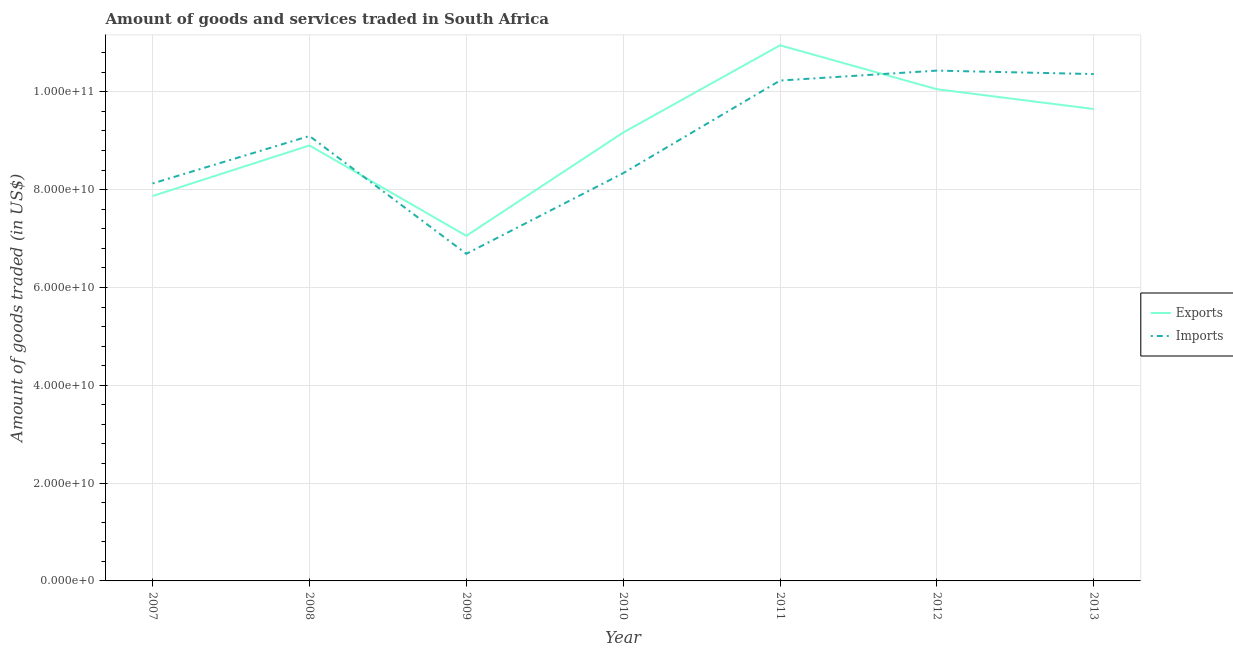How many different coloured lines are there?
Your answer should be very brief. 2. What is the amount of goods imported in 2012?
Keep it short and to the point. 1.04e+11. Across all years, what is the maximum amount of goods imported?
Offer a very short reply. 1.04e+11. Across all years, what is the minimum amount of goods imported?
Offer a very short reply. 6.69e+1. In which year was the amount of goods exported maximum?
Offer a terse response. 2011. In which year was the amount of goods exported minimum?
Keep it short and to the point. 2009. What is the total amount of goods exported in the graph?
Keep it short and to the point. 6.36e+11. What is the difference between the amount of goods exported in 2007 and that in 2008?
Provide a short and direct response. -1.03e+1. What is the difference between the amount of goods exported in 2010 and the amount of goods imported in 2008?
Your answer should be compact. 7.09e+08. What is the average amount of goods imported per year?
Your response must be concise. 9.04e+1. In the year 2010, what is the difference between the amount of goods exported and amount of goods imported?
Ensure brevity in your answer.  8.31e+09. In how many years, is the amount of goods exported greater than 92000000000 US$?
Make the answer very short. 3. What is the ratio of the amount of goods imported in 2007 to that in 2011?
Ensure brevity in your answer.  0.79. What is the difference between the highest and the second highest amount of goods exported?
Provide a short and direct response. 8.98e+09. What is the difference between the highest and the lowest amount of goods imported?
Offer a terse response. 3.75e+1. In how many years, is the amount of goods imported greater than the average amount of goods imported taken over all years?
Your response must be concise. 4. Is the amount of goods exported strictly greater than the amount of goods imported over the years?
Your answer should be very brief. No. How many years are there in the graph?
Provide a succinct answer. 7. What is the difference between two consecutive major ticks on the Y-axis?
Provide a short and direct response. 2.00e+1. Does the graph contain any zero values?
Ensure brevity in your answer.  No. Where does the legend appear in the graph?
Offer a terse response. Center right. How many legend labels are there?
Your response must be concise. 2. What is the title of the graph?
Provide a succinct answer. Amount of goods and services traded in South Africa. Does "Not attending school" appear as one of the legend labels in the graph?
Make the answer very short. No. What is the label or title of the X-axis?
Make the answer very short. Year. What is the label or title of the Y-axis?
Make the answer very short. Amount of goods traded (in US$). What is the Amount of goods traded (in US$) of Exports in 2007?
Provide a short and direct response. 7.87e+1. What is the Amount of goods traded (in US$) of Imports in 2007?
Keep it short and to the point. 8.13e+1. What is the Amount of goods traded (in US$) of Exports in 2008?
Offer a very short reply. 8.90e+1. What is the Amount of goods traded (in US$) of Imports in 2008?
Offer a terse response. 9.10e+1. What is the Amount of goods traded (in US$) of Exports in 2009?
Keep it short and to the point. 7.06e+1. What is the Amount of goods traded (in US$) of Imports in 2009?
Give a very brief answer. 6.69e+1. What is the Amount of goods traded (in US$) of Exports in 2010?
Give a very brief answer. 9.17e+1. What is the Amount of goods traded (in US$) in Imports in 2010?
Give a very brief answer. 8.34e+1. What is the Amount of goods traded (in US$) of Exports in 2011?
Offer a very short reply. 1.10e+11. What is the Amount of goods traded (in US$) of Imports in 2011?
Your answer should be very brief. 1.02e+11. What is the Amount of goods traded (in US$) of Exports in 2012?
Your answer should be very brief. 1.01e+11. What is the Amount of goods traded (in US$) in Imports in 2012?
Provide a succinct answer. 1.04e+11. What is the Amount of goods traded (in US$) of Exports in 2013?
Your response must be concise. 9.65e+1. What is the Amount of goods traded (in US$) in Imports in 2013?
Give a very brief answer. 1.04e+11. Across all years, what is the maximum Amount of goods traded (in US$) in Exports?
Keep it short and to the point. 1.10e+11. Across all years, what is the maximum Amount of goods traded (in US$) of Imports?
Your answer should be compact. 1.04e+11. Across all years, what is the minimum Amount of goods traded (in US$) of Exports?
Offer a terse response. 7.06e+1. Across all years, what is the minimum Amount of goods traded (in US$) in Imports?
Provide a succinct answer. 6.69e+1. What is the total Amount of goods traded (in US$) of Exports in the graph?
Ensure brevity in your answer.  6.36e+11. What is the total Amount of goods traded (in US$) in Imports in the graph?
Provide a short and direct response. 6.33e+11. What is the difference between the Amount of goods traded (in US$) in Exports in 2007 and that in 2008?
Your answer should be very brief. -1.03e+1. What is the difference between the Amount of goods traded (in US$) of Imports in 2007 and that in 2008?
Your response must be concise. -9.70e+09. What is the difference between the Amount of goods traded (in US$) of Exports in 2007 and that in 2009?
Give a very brief answer. 8.14e+09. What is the difference between the Amount of goods traded (in US$) of Imports in 2007 and that in 2009?
Give a very brief answer. 1.44e+1. What is the difference between the Amount of goods traded (in US$) of Exports in 2007 and that in 2010?
Provide a succinct answer. -1.30e+1. What is the difference between the Amount of goods traded (in US$) in Imports in 2007 and that in 2010?
Your answer should be compact. -2.10e+09. What is the difference between the Amount of goods traded (in US$) in Exports in 2007 and that in 2011?
Provide a short and direct response. -3.08e+1. What is the difference between the Amount of goods traded (in US$) of Imports in 2007 and that in 2011?
Keep it short and to the point. -2.10e+1. What is the difference between the Amount of goods traded (in US$) in Exports in 2007 and that in 2012?
Give a very brief answer. -2.18e+1. What is the difference between the Amount of goods traded (in US$) in Imports in 2007 and that in 2012?
Keep it short and to the point. -2.31e+1. What is the difference between the Amount of goods traded (in US$) in Exports in 2007 and that in 2013?
Your response must be concise. -1.78e+1. What is the difference between the Amount of goods traded (in US$) in Imports in 2007 and that in 2013?
Offer a very short reply. -2.24e+1. What is the difference between the Amount of goods traded (in US$) in Exports in 2008 and that in 2009?
Your response must be concise. 1.85e+1. What is the difference between the Amount of goods traded (in US$) of Imports in 2008 and that in 2009?
Your answer should be very brief. 2.41e+1. What is the difference between the Amount of goods traded (in US$) of Exports in 2008 and that in 2010?
Ensure brevity in your answer.  -2.64e+09. What is the difference between the Amount of goods traded (in US$) in Imports in 2008 and that in 2010?
Offer a terse response. 7.60e+09. What is the difference between the Amount of goods traded (in US$) in Exports in 2008 and that in 2011?
Give a very brief answer. -2.05e+1. What is the difference between the Amount of goods traded (in US$) of Imports in 2008 and that in 2011?
Provide a succinct answer. -1.13e+1. What is the difference between the Amount of goods traded (in US$) in Exports in 2008 and that in 2012?
Make the answer very short. -1.15e+1. What is the difference between the Amount of goods traded (in US$) of Imports in 2008 and that in 2012?
Offer a very short reply. -1.34e+1. What is the difference between the Amount of goods traded (in US$) of Exports in 2008 and that in 2013?
Offer a terse response. -7.45e+09. What is the difference between the Amount of goods traded (in US$) of Imports in 2008 and that in 2013?
Provide a short and direct response. -1.27e+1. What is the difference between the Amount of goods traded (in US$) in Exports in 2009 and that in 2010?
Provide a short and direct response. -2.11e+1. What is the difference between the Amount of goods traded (in US$) of Imports in 2009 and that in 2010?
Keep it short and to the point. -1.65e+1. What is the difference between the Amount of goods traded (in US$) of Exports in 2009 and that in 2011?
Your response must be concise. -3.90e+1. What is the difference between the Amount of goods traded (in US$) in Imports in 2009 and that in 2011?
Your response must be concise. -3.54e+1. What is the difference between the Amount of goods traded (in US$) in Exports in 2009 and that in 2012?
Provide a succinct answer. -3.00e+1. What is the difference between the Amount of goods traded (in US$) in Imports in 2009 and that in 2012?
Your answer should be very brief. -3.75e+1. What is the difference between the Amount of goods traded (in US$) in Exports in 2009 and that in 2013?
Provide a succinct answer. -2.59e+1. What is the difference between the Amount of goods traded (in US$) in Imports in 2009 and that in 2013?
Ensure brevity in your answer.  -3.67e+1. What is the difference between the Amount of goods traded (in US$) in Exports in 2010 and that in 2011?
Keep it short and to the point. -1.78e+1. What is the difference between the Amount of goods traded (in US$) in Imports in 2010 and that in 2011?
Ensure brevity in your answer.  -1.89e+1. What is the difference between the Amount of goods traded (in US$) in Exports in 2010 and that in 2012?
Keep it short and to the point. -8.85e+09. What is the difference between the Amount of goods traded (in US$) of Imports in 2010 and that in 2012?
Your answer should be compact. -2.10e+1. What is the difference between the Amount of goods traded (in US$) of Exports in 2010 and that in 2013?
Make the answer very short. -4.81e+09. What is the difference between the Amount of goods traded (in US$) in Imports in 2010 and that in 2013?
Your answer should be compact. -2.03e+1. What is the difference between the Amount of goods traded (in US$) of Exports in 2011 and that in 2012?
Make the answer very short. 8.98e+09. What is the difference between the Amount of goods traded (in US$) in Imports in 2011 and that in 2012?
Your answer should be compact. -2.03e+09. What is the difference between the Amount of goods traded (in US$) of Exports in 2011 and that in 2013?
Offer a very short reply. 1.30e+1. What is the difference between the Amount of goods traded (in US$) of Imports in 2011 and that in 2013?
Provide a short and direct response. -1.33e+09. What is the difference between the Amount of goods traded (in US$) in Exports in 2012 and that in 2013?
Your answer should be very brief. 4.04e+09. What is the difference between the Amount of goods traded (in US$) of Imports in 2012 and that in 2013?
Make the answer very short. 7.08e+08. What is the difference between the Amount of goods traded (in US$) in Exports in 2007 and the Amount of goods traded (in US$) in Imports in 2008?
Offer a very short reply. -1.23e+1. What is the difference between the Amount of goods traded (in US$) in Exports in 2007 and the Amount of goods traded (in US$) in Imports in 2009?
Provide a short and direct response. 1.18e+1. What is the difference between the Amount of goods traded (in US$) in Exports in 2007 and the Amount of goods traded (in US$) in Imports in 2010?
Your answer should be compact. -4.67e+09. What is the difference between the Amount of goods traded (in US$) of Exports in 2007 and the Amount of goods traded (in US$) of Imports in 2011?
Make the answer very short. -2.36e+1. What is the difference between the Amount of goods traded (in US$) in Exports in 2007 and the Amount of goods traded (in US$) in Imports in 2012?
Offer a terse response. -2.56e+1. What is the difference between the Amount of goods traded (in US$) of Exports in 2007 and the Amount of goods traded (in US$) of Imports in 2013?
Your response must be concise. -2.49e+1. What is the difference between the Amount of goods traded (in US$) in Exports in 2008 and the Amount of goods traded (in US$) in Imports in 2009?
Offer a terse response. 2.21e+1. What is the difference between the Amount of goods traded (in US$) of Exports in 2008 and the Amount of goods traded (in US$) of Imports in 2010?
Offer a terse response. 5.67e+09. What is the difference between the Amount of goods traded (in US$) of Exports in 2008 and the Amount of goods traded (in US$) of Imports in 2011?
Your answer should be very brief. -1.33e+1. What is the difference between the Amount of goods traded (in US$) in Exports in 2008 and the Amount of goods traded (in US$) in Imports in 2012?
Offer a very short reply. -1.53e+1. What is the difference between the Amount of goods traded (in US$) of Exports in 2008 and the Amount of goods traded (in US$) of Imports in 2013?
Your response must be concise. -1.46e+1. What is the difference between the Amount of goods traded (in US$) of Exports in 2009 and the Amount of goods traded (in US$) of Imports in 2010?
Your answer should be very brief. -1.28e+1. What is the difference between the Amount of goods traded (in US$) of Exports in 2009 and the Amount of goods traded (in US$) of Imports in 2011?
Your answer should be very brief. -3.17e+1. What is the difference between the Amount of goods traded (in US$) in Exports in 2009 and the Amount of goods traded (in US$) in Imports in 2012?
Your answer should be compact. -3.38e+1. What is the difference between the Amount of goods traded (in US$) of Exports in 2009 and the Amount of goods traded (in US$) of Imports in 2013?
Provide a short and direct response. -3.31e+1. What is the difference between the Amount of goods traded (in US$) of Exports in 2010 and the Amount of goods traded (in US$) of Imports in 2011?
Provide a short and direct response. -1.06e+1. What is the difference between the Amount of goods traded (in US$) in Exports in 2010 and the Amount of goods traded (in US$) in Imports in 2012?
Keep it short and to the point. -1.27e+1. What is the difference between the Amount of goods traded (in US$) of Exports in 2010 and the Amount of goods traded (in US$) of Imports in 2013?
Ensure brevity in your answer.  -1.20e+1. What is the difference between the Amount of goods traded (in US$) in Exports in 2011 and the Amount of goods traded (in US$) in Imports in 2012?
Offer a very short reply. 5.17e+09. What is the difference between the Amount of goods traded (in US$) of Exports in 2011 and the Amount of goods traded (in US$) of Imports in 2013?
Make the answer very short. 5.88e+09. What is the difference between the Amount of goods traded (in US$) of Exports in 2012 and the Amount of goods traded (in US$) of Imports in 2013?
Provide a succinct answer. -3.10e+09. What is the average Amount of goods traded (in US$) in Exports per year?
Ensure brevity in your answer.  9.09e+1. What is the average Amount of goods traded (in US$) of Imports per year?
Offer a very short reply. 9.04e+1. In the year 2007, what is the difference between the Amount of goods traded (in US$) of Exports and Amount of goods traded (in US$) of Imports?
Provide a short and direct response. -2.57e+09. In the year 2008, what is the difference between the Amount of goods traded (in US$) in Exports and Amount of goods traded (in US$) in Imports?
Your response must be concise. -1.93e+09. In the year 2009, what is the difference between the Amount of goods traded (in US$) of Exports and Amount of goods traded (in US$) of Imports?
Provide a succinct answer. 3.67e+09. In the year 2010, what is the difference between the Amount of goods traded (in US$) in Exports and Amount of goods traded (in US$) in Imports?
Offer a very short reply. 8.31e+09. In the year 2011, what is the difference between the Amount of goods traded (in US$) of Exports and Amount of goods traded (in US$) of Imports?
Provide a short and direct response. 7.21e+09. In the year 2012, what is the difference between the Amount of goods traded (in US$) in Exports and Amount of goods traded (in US$) in Imports?
Ensure brevity in your answer.  -3.81e+09. In the year 2013, what is the difference between the Amount of goods traded (in US$) of Exports and Amount of goods traded (in US$) of Imports?
Provide a succinct answer. -7.14e+09. What is the ratio of the Amount of goods traded (in US$) in Exports in 2007 to that in 2008?
Offer a very short reply. 0.88. What is the ratio of the Amount of goods traded (in US$) of Imports in 2007 to that in 2008?
Offer a terse response. 0.89. What is the ratio of the Amount of goods traded (in US$) of Exports in 2007 to that in 2009?
Ensure brevity in your answer.  1.12. What is the ratio of the Amount of goods traded (in US$) in Imports in 2007 to that in 2009?
Provide a short and direct response. 1.22. What is the ratio of the Amount of goods traded (in US$) in Exports in 2007 to that in 2010?
Offer a terse response. 0.86. What is the ratio of the Amount of goods traded (in US$) of Imports in 2007 to that in 2010?
Your answer should be very brief. 0.97. What is the ratio of the Amount of goods traded (in US$) of Exports in 2007 to that in 2011?
Give a very brief answer. 0.72. What is the ratio of the Amount of goods traded (in US$) of Imports in 2007 to that in 2011?
Offer a very short reply. 0.79. What is the ratio of the Amount of goods traded (in US$) of Exports in 2007 to that in 2012?
Provide a succinct answer. 0.78. What is the ratio of the Amount of goods traded (in US$) in Imports in 2007 to that in 2012?
Keep it short and to the point. 0.78. What is the ratio of the Amount of goods traded (in US$) in Exports in 2007 to that in 2013?
Offer a very short reply. 0.82. What is the ratio of the Amount of goods traded (in US$) in Imports in 2007 to that in 2013?
Provide a succinct answer. 0.78. What is the ratio of the Amount of goods traded (in US$) of Exports in 2008 to that in 2009?
Your answer should be very brief. 1.26. What is the ratio of the Amount of goods traded (in US$) of Imports in 2008 to that in 2009?
Offer a terse response. 1.36. What is the ratio of the Amount of goods traded (in US$) of Exports in 2008 to that in 2010?
Offer a terse response. 0.97. What is the ratio of the Amount of goods traded (in US$) in Imports in 2008 to that in 2010?
Offer a terse response. 1.09. What is the ratio of the Amount of goods traded (in US$) in Exports in 2008 to that in 2011?
Keep it short and to the point. 0.81. What is the ratio of the Amount of goods traded (in US$) of Imports in 2008 to that in 2011?
Make the answer very short. 0.89. What is the ratio of the Amount of goods traded (in US$) of Exports in 2008 to that in 2012?
Make the answer very short. 0.89. What is the ratio of the Amount of goods traded (in US$) of Imports in 2008 to that in 2012?
Ensure brevity in your answer.  0.87. What is the ratio of the Amount of goods traded (in US$) of Exports in 2008 to that in 2013?
Your answer should be very brief. 0.92. What is the ratio of the Amount of goods traded (in US$) of Imports in 2008 to that in 2013?
Make the answer very short. 0.88. What is the ratio of the Amount of goods traded (in US$) in Exports in 2009 to that in 2010?
Offer a very short reply. 0.77. What is the ratio of the Amount of goods traded (in US$) of Imports in 2009 to that in 2010?
Your answer should be compact. 0.8. What is the ratio of the Amount of goods traded (in US$) in Exports in 2009 to that in 2011?
Ensure brevity in your answer.  0.64. What is the ratio of the Amount of goods traded (in US$) of Imports in 2009 to that in 2011?
Give a very brief answer. 0.65. What is the ratio of the Amount of goods traded (in US$) in Exports in 2009 to that in 2012?
Offer a terse response. 0.7. What is the ratio of the Amount of goods traded (in US$) of Imports in 2009 to that in 2012?
Make the answer very short. 0.64. What is the ratio of the Amount of goods traded (in US$) of Exports in 2009 to that in 2013?
Keep it short and to the point. 0.73. What is the ratio of the Amount of goods traded (in US$) of Imports in 2009 to that in 2013?
Provide a short and direct response. 0.65. What is the ratio of the Amount of goods traded (in US$) of Exports in 2010 to that in 2011?
Offer a very short reply. 0.84. What is the ratio of the Amount of goods traded (in US$) of Imports in 2010 to that in 2011?
Your answer should be very brief. 0.81. What is the ratio of the Amount of goods traded (in US$) in Exports in 2010 to that in 2012?
Keep it short and to the point. 0.91. What is the ratio of the Amount of goods traded (in US$) of Imports in 2010 to that in 2012?
Make the answer very short. 0.8. What is the ratio of the Amount of goods traded (in US$) of Exports in 2010 to that in 2013?
Keep it short and to the point. 0.95. What is the ratio of the Amount of goods traded (in US$) in Imports in 2010 to that in 2013?
Make the answer very short. 0.8. What is the ratio of the Amount of goods traded (in US$) of Exports in 2011 to that in 2012?
Your answer should be compact. 1.09. What is the ratio of the Amount of goods traded (in US$) in Imports in 2011 to that in 2012?
Offer a terse response. 0.98. What is the ratio of the Amount of goods traded (in US$) in Exports in 2011 to that in 2013?
Your answer should be very brief. 1.14. What is the ratio of the Amount of goods traded (in US$) of Imports in 2011 to that in 2013?
Give a very brief answer. 0.99. What is the ratio of the Amount of goods traded (in US$) of Exports in 2012 to that in 2013?
Offer a very short reply. 1.04. What is the ratio of the Amount of goods traded (in US$) in Imports in 2012 to that in 2013?
Your response must be concise. 1.01. What is the difference between the highest and the second highest Amount of goods traded (in US$) in Exports?
Keep it short and to the point. 8.98e+09. What is the difference between the highest and the second highest Amount of goods traded (in US$) in Imports?
Provide a succinct answer. 7.08e+08. What is the difference between the highest and the lowest Amount of goods traded (in US$) of Exports?
Ensure brevity in your answer.  3.90e+1. What is the difference between the highest and the lowest Amount of goods traded (in US$) of Imports?
Your response must be concise. 3.75e+1. 